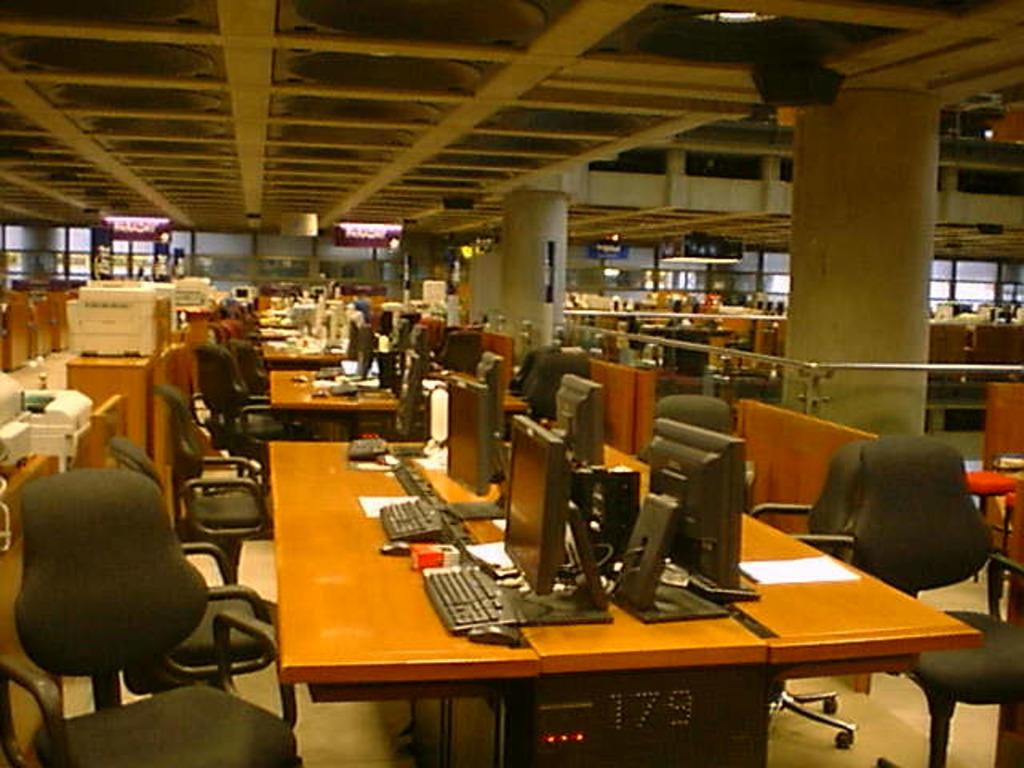What type of space is depicted in the image? The image is of a room. What furniture is present in the room? There are tables and chairs in the room. What electronic devices can be seen on the tables? There are computers, keyboards, and mouses on the tables. What type of lighting is present in the room? There are lights at the top of the room. What type of paper is being coughed up by the earth in the image? There is no paper, coughing, or earth present in the image. The image depicts a room with tables, chairs, and electronic devices. 